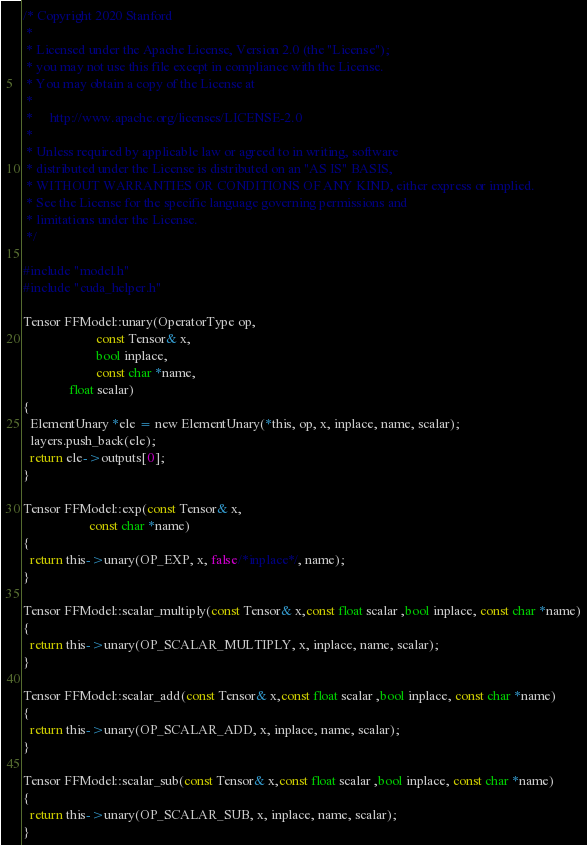Convert code to text. <code><loc_0><loc_0><loc_500><loc_500><_Cuda_>/* Copyright 2020 Stanford
 *
 * Licensed under the Apache License, Version 2.0 (the "License");
 * you may not use this file except in compliance with the License.
 * You may obtain a copy of the License at
 *
 *     http://www.apache.org/licenses/LICENSE-2.0
 *
 * Unless required by applicable law or agreed to in writing, software
 * distributed under the License is distributed on an "AS IS" BASIS,
 * WITHOUT WARRANTIES OR CONDITIONS OF ANY KIND, either express or implied.
 * See the License for the specific language governing permissions and
 * limitations under the License.
 */

#include "model.h"
#include "cuda_helper.h"

Tensor FFModel::unary(OperatorType op,
                      const Tensor& x,
                      bool inplace,
                      const char *name,
		      float scalar)
{
  ElementUnary *ele = new ElementUnary(*this, op, x, inplace, name, scalar);
  layers.push_back(ele);
  return ele->outputs[0];
}

Tensor FFModel::exp(const Tensor& x,
                    const char *name)
{
  return this->unary(OP_EXP, x, false/*inplace*/, name);
}

Tensor FFModel::scalar_multiply(const Tensor& x,const float scalar ,bool inplace, const char *name)
{
  return this->unary(OP_SCALAR_MULTIPLY, x, inplace, name, scalar);
}

Tensor FFModel::scalar_add(const Tensor& x,const float scalar ,bool inplace, const char *name)
{
  return this->unary(OP_SCALAR_ADD, x, inplace, name, scalar);
}

Tensor FFModel::scalar_sub(const Tensor& x,const float scalar ,bool inplace, const char *name)
{
  return this->unary(OP_SCALAR_SUB, x, inplace, name, scalar);
}
</code> 